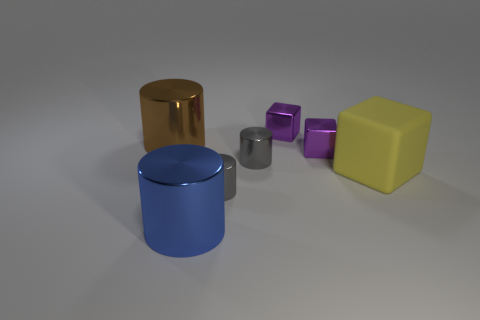Is there anything else that is made of the same material as the big block?
Offer a very short reply. No. How many other yellow blocks have the same size as the yellow cube?
Your answer should be compact. 0. How many blue cylinders are behind the purple object in front of the big brown metal object?
Offer a very short reply. 0. What size is the cylinder that is both on the right side of the large blue object and in front of the large matte object?
Provide a short and direct response. Small. Are there more cyan objects than large yellow rubber blocks?
Keep it short and to the point. No. Is there a tiny matte sphere that has the same color as the big rubber cube?
Ensure brevity in your answer.  No. There is a purple thing in front of the brown shiny thing; is its size the same as the large brown object?
Offer a very short reply. No. Is the number of cylinders less than the number of yellow matte objects?
Offer a very short reply. No. Are there any big cylinders that have the same material as the blue thing?
Your answer should be compact. Yes. There is a large metal thing that is left of the big blue object; what shape is it?
Make the answer very short. Cylinder. 